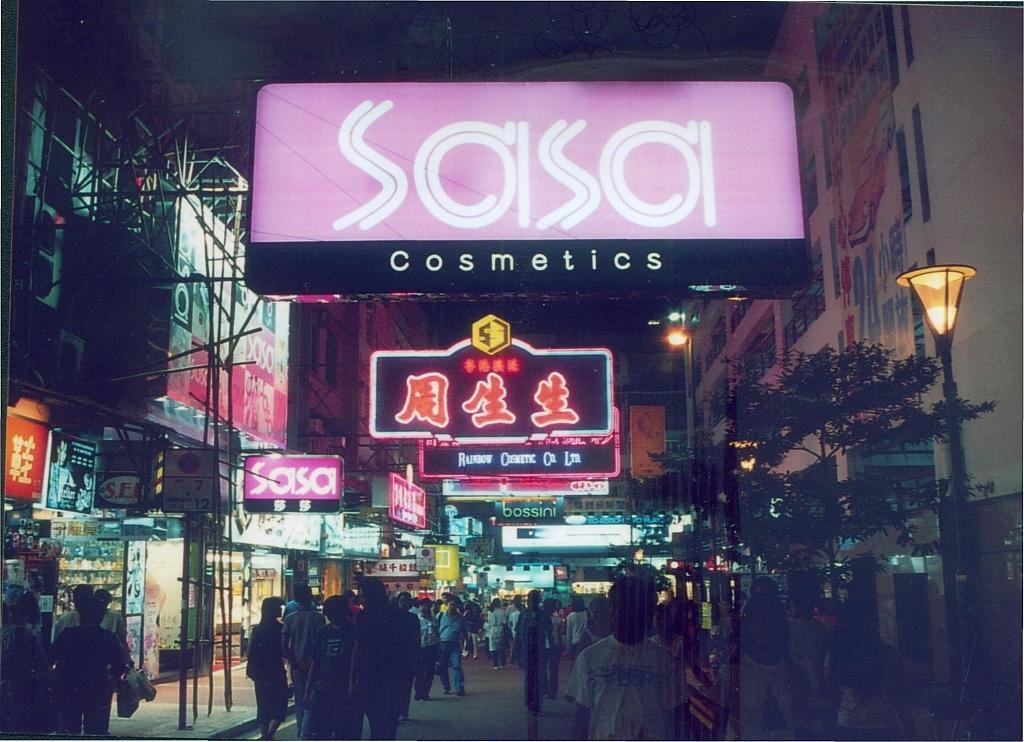How would you summarize this image in a sentence or two? In this image we can see the people walking on the road and we can see the buildings on the left and right side. And there are boards with text and logos and few objects. 